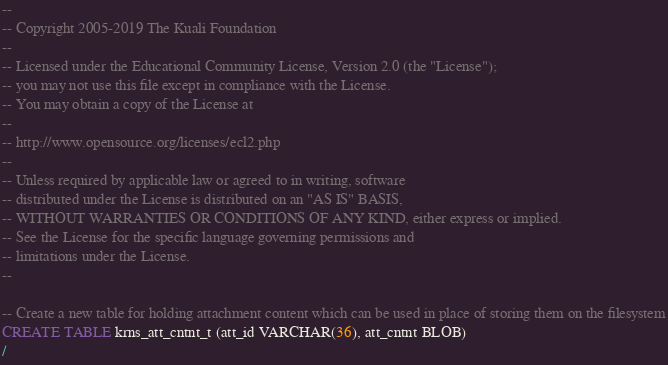<code> <loc_0><loc_0><loc_500><loc_500><_SQL_>--
-- Copyright 2005-2019 The Kuali Foundation
--
-- Licensed under the Educational Community License, Version 2.0 (the "License");
-- you may not use this file except in compliance with the License.
-- You may obtain a copy of the License at
--
-- http://www.opensource.org/licenses/ecl2.php
--
-- Unless required by applicable law or agreed to in writing, software
-- distributed under the License is distributed on an "AS IS" BASIS,
-- WITHOUT WARRANTIES OR CONDITIONS OF ANY KIND, either express or implied.
-- See the License for the specific language governing permissions and
-- limitations under the License.
--

-- Create a new table for holding attachment content which can be used in place of storing them on the filesystem
CREATE TABLE krns_att_cntnt_t (att_id VARCHAR(36), att_cntnt BLOB)
/
</code> 